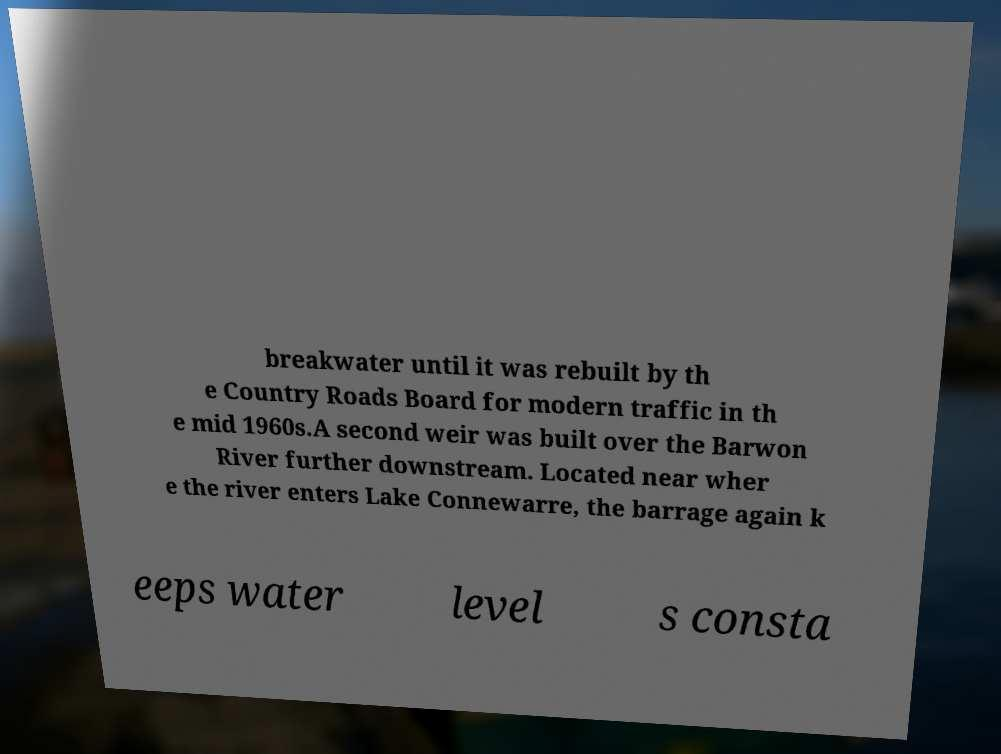Please identify and transcribe the text found in this image. breakwater until it was rebuilt by th e Country Roads Board for modern traffic in th e mid 1960s.A second weir was built over the Barwon River further downstream. Located near wher e the river enters Lake Connewarre, the barrage again k eeps water level s consta 